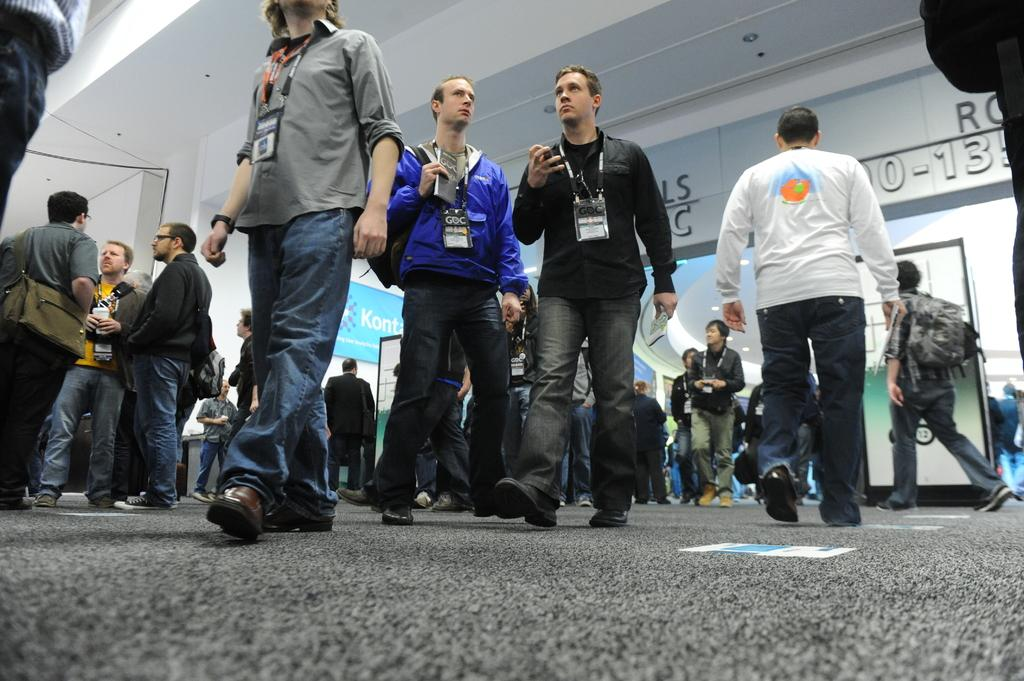Who or what can be seen in the image? There are people in the image. What can be seen in the background of the image? There are posters in the background of the image. What is at the top side of the image? There is a roof at the top side of the image. What invention is being approved by the people in the image? There is no invention or approval process depicted in the image; it simply shows people and posters in the background. 